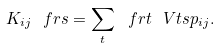<formula> <loc_0><loc_0><loc_500><loc_500>K _ { i j } \ f { r s } = \sum _ { t } \ f { r t } \ V { t s } { p _ { i j } } .</formula> 